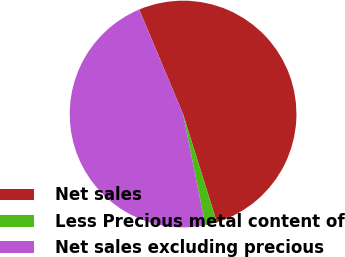<chart> <loc_0><loc_0><loc_500><loc_500><pie_chart><fcel>Net sales<fcel>Less Precious metal content of<fcel>Net sales excluding precious<nl><fcel>51.5%<fcel>1.68%<fcel>46.82%<nl></chart> 